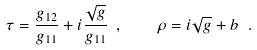<formula> <loc_0><loc_0><loc_500><loc_500>\tau = \frac { g _ { 1 2 } } { g _ { 1 1 } } + i \frac { \sqrt { g } } { g _ { 1 1 } } \ , \quad \rho = i \sqrt { g } + b \ .</formula> 